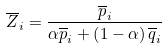<formula> <loc_0><loc_0><loc_500><loc_500>\overline { Z } _ { i } = \frac { \overline { p } _ { i } } { \alpha \overline { p } _ { i } + \left ( 1 - \alpha \right ) \overline { q } _ { i } }</formula> 